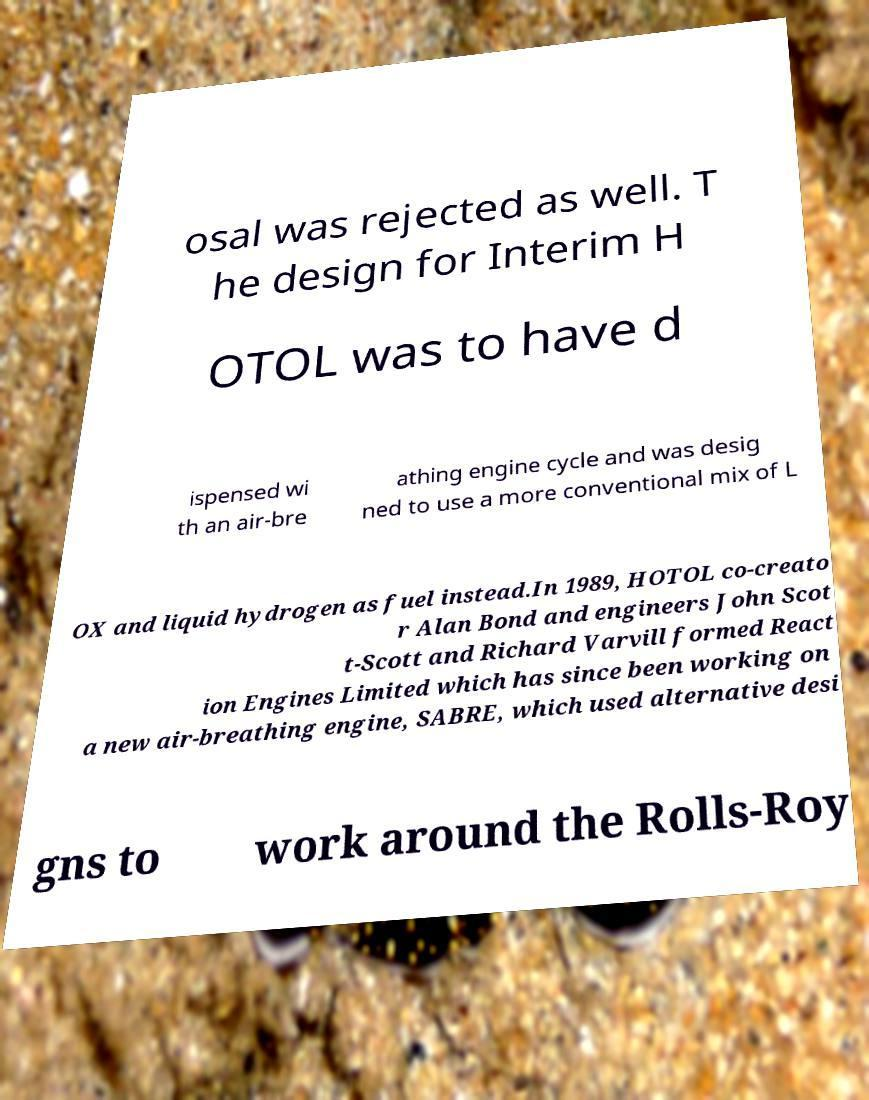Can you read and provide the text displayed in the image?This photo seems to have some interesting text. Can you extract and type it out for me? osal was rejected as well. T he design for Interim H OTOL was to have d ispensed wi th an air-bre athing engine cycle and was desig ned to use a more conventional mix of L OX and liquid hydrogen as fuel instead.In 1989, HOTOL co-creato r Alan Bond and engineers John Scot t-Scott and Richard Varvill formed React ion Engines Limited which has since been working on a new air-breathing engine, SABRE, which used alternative desi gns to work around the Rolls-Roy 